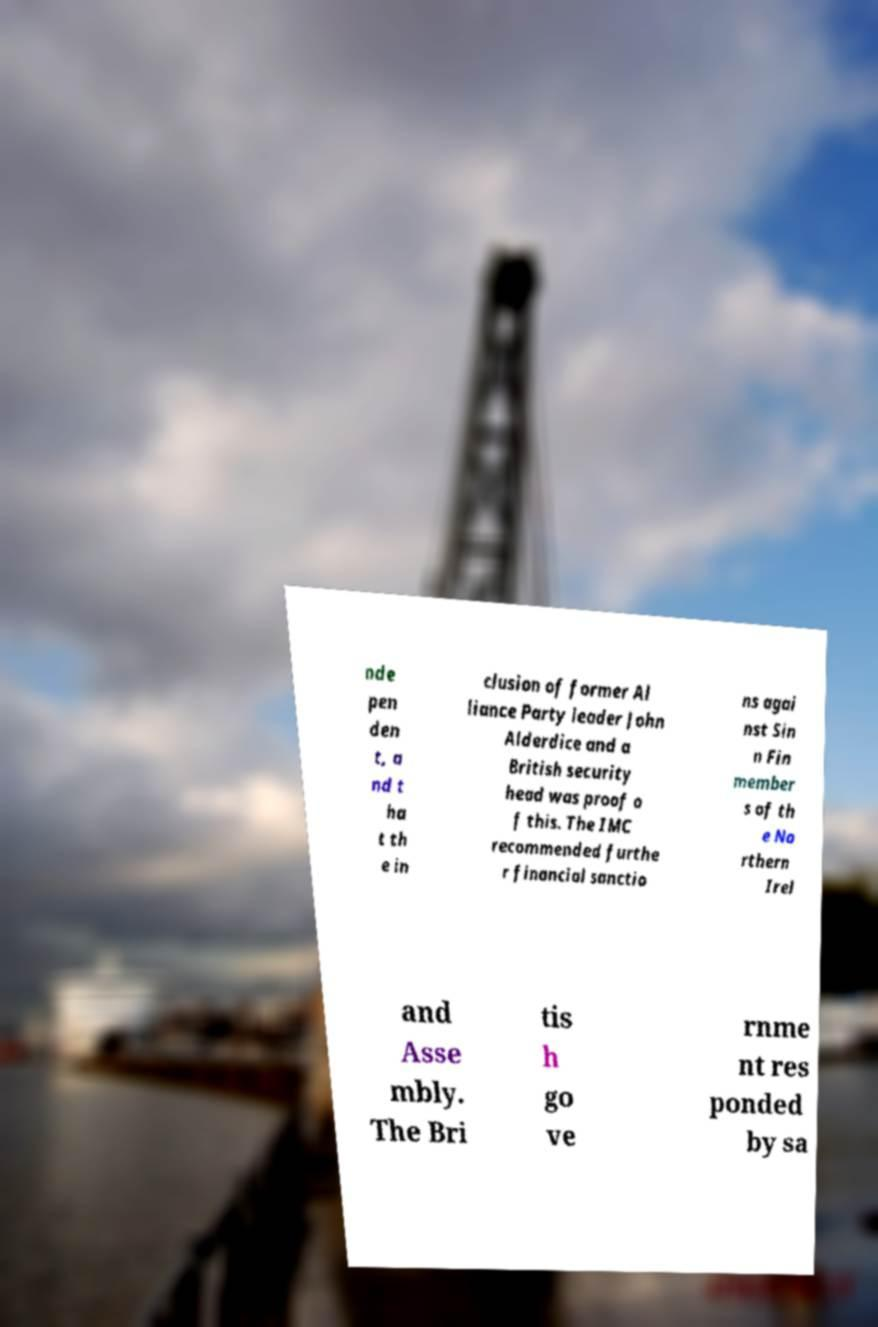I need the written content from this picture converted into text. Can you do that? nde pen den t, a nd t ha t th e in clusion of former Al liance Party leader John Alderdice and a British security head was proof o f this. The IMC recommended furthe r financial sanctio ns agai nst Sin n Fin member s of th e No rthern Irel and Asse mbly. The Bri tis h go ve rnme nt res ponded by sa 